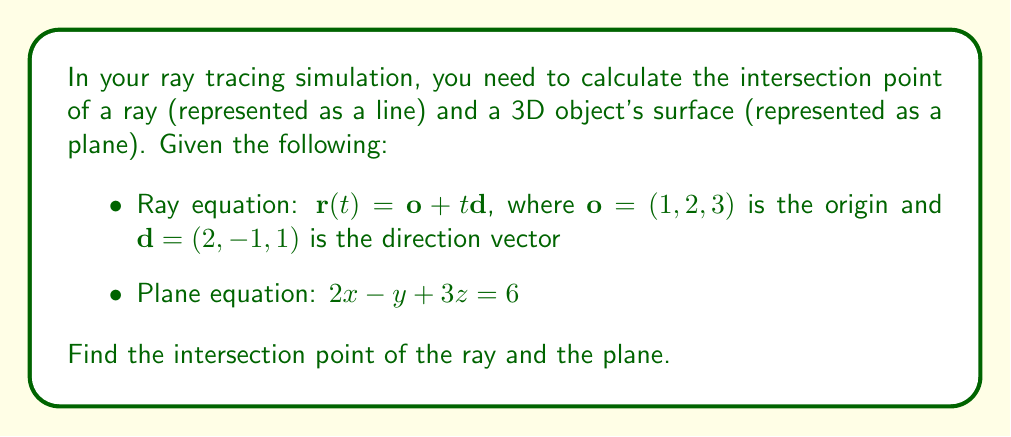Solve this math problem. To find the intersection point, we need to solve the system of equations formed by the ray and plane equations:

1) Substitute the ray equation into the plane equation:
   $2(1 + 2t) - (2 - t) + 3(3 + t) = 6$

2) Simplify:
   $2 + 4t - 2 + t + 9 + 3t = 6$
   $9 + 8t = 6$

3) Solve for $t$:
   $8t = -3$
   $t = -\frac{3}{8}$

4) Substitute $t$ back into the ray equation to find the intersection point:
   $\mathbf{r}(-\frac{3}{8}) = (1, 2, 3) + (-\frac{3}{8})(2, -1, 1)$
   
   $x = 1 + (-\frac{3}{8})(2) = 1 - \frac{3}{4} = \frac{1}{4}$
   $y = 2 + (-\frac{3}{8})(-1) = 2 + \frac{3}{8} = \frac{19}{8}$
   $z = 3 + (-\frac{3}{8})(1) = 3 - \frac{3}{8} = \frac{21}{8}$

Therefore, the intersection point is $(\frac{1}{4}, \frac{19}{8}, \frac{21}{8})$.
Answer: $(\frac{1}{4}, \frac{19}{8}, \frac{21}{8})$ 